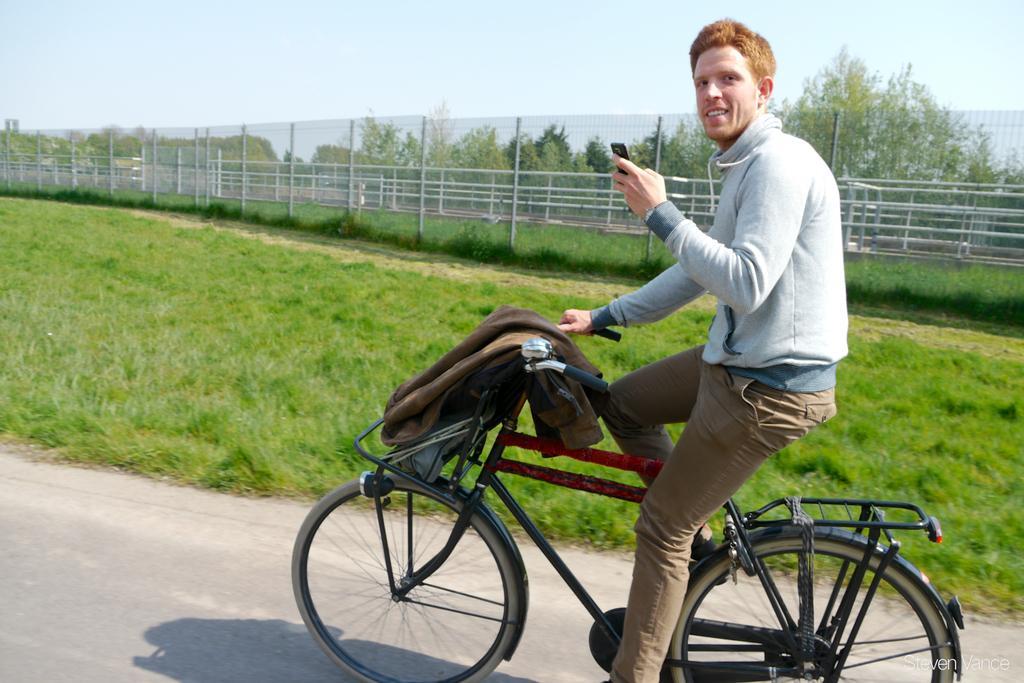Please provide a concise description of this image. This picture is clicked outside the city. Here, we see a man in grey jacket is riding bicycle and he is carrying mobile phone in his hand. Beside him, we see grass and beside grass, there is a fence and behind that, we see trees and sky. 